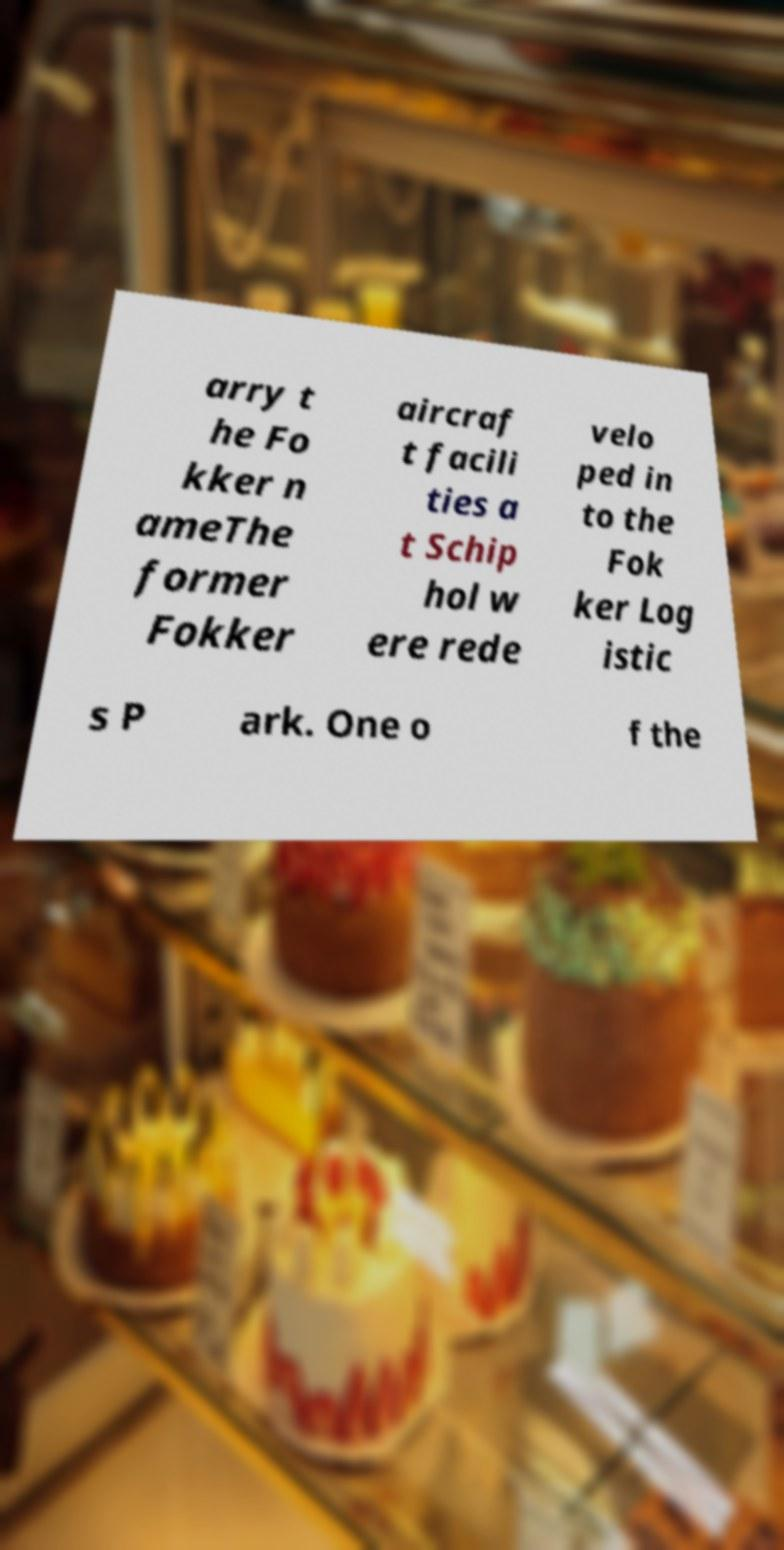Can you accurately transcribe the text from the provided image for me? arry t he Fo kker n ameThe former Fokker aircraf t facili ties a t Schip hol w ere rede velo ped in to the Fok ker Log istic s P ark. One o f the 